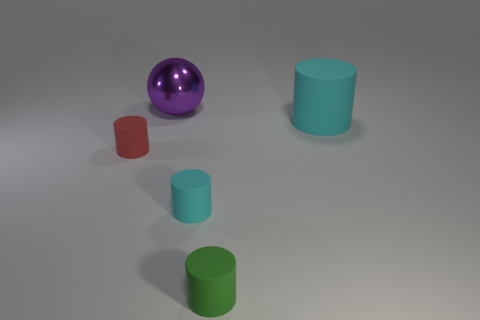Is the large object that is in front of the metallic thing made of the same material as the red object on the left side of the small cyan cylinder?
Offer a very short reply. Yes. There is a object that is behind the large cyan matte cylinder; what material is it?
Your response must be concise. Metal. What number of matte objects are either cylinders or cyan objects?
Offer a very short reply. 4. The cylinder behind the small cylinder that is on the left side of the large purple sphere is what color?
Offer a very short reply. Cyan. Are the red object and the cyan cylinder behind the small red rubber object made of the same material?
Make the answer very short. Yes. What color is the big object left of the small green cylinder on the right side of the cyan cylinder that is in front of the red cylinder?
Provide a succinct answer. Purple. Is there anything else that is the same shape as the large purple metal thing?
Provide a succinct answer. No. Are there more brown cubes than small green rubber things?
Give a very brief answer. No. What number of tiny matte things are both on the right side of the red cylinder and left of the purple metallic sphere?
Your response must be concise. 0. What number of small cylinders are right of the cyan rubber cylinder in front of the big cyan object?
Provide a short and direct response. 1. 